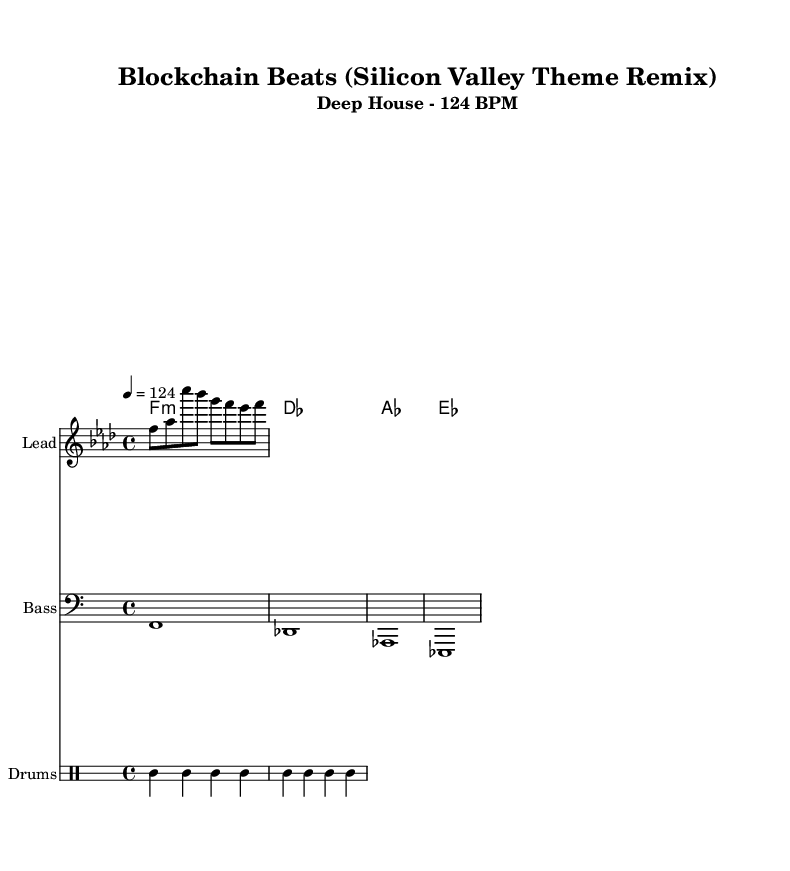What is the key signature of this music? The key signature is F minor, indicated by the presence of four flats (B, E, A, D) and the use of the note F as the tonic.
Answer: F minor What is the time signature of this music? The time signature is 4/4, which is commonly indicated at the beginning of the score and denotes four beats in a measure.
Answer: 4/4 What is the tempo of this music? The tempo is marked as 124 BPM (beats per minute), which suggests a moderate pace typical for deep house music.
Answer: 124 BPM What is the main instrument in the melody? The main instrument for the melody is indicated as "Lead," which suggests that this part is played on an instrument that carries the primary melodic line.
Answer: Lead How many measures does the melody contain? The melody is presented in a series of notes; counting the notes and their respective groupings shows that there are four measures in total.
Answer: 4 What kind of chords are used in the harmony? The harmony consists of minor chords, specifically F minor, D♭ major, A♭ major, and E♭ major, which aligns with the overall mood of deep house music.
Answer: Minor chords What percussion instruments are used in this music? The percussion part includes bass drums, hi-hats, and snare drums, common components in deep house beats, creating a rich rhythmic texture.
Answer: Bass drum, hi-hat, snare 